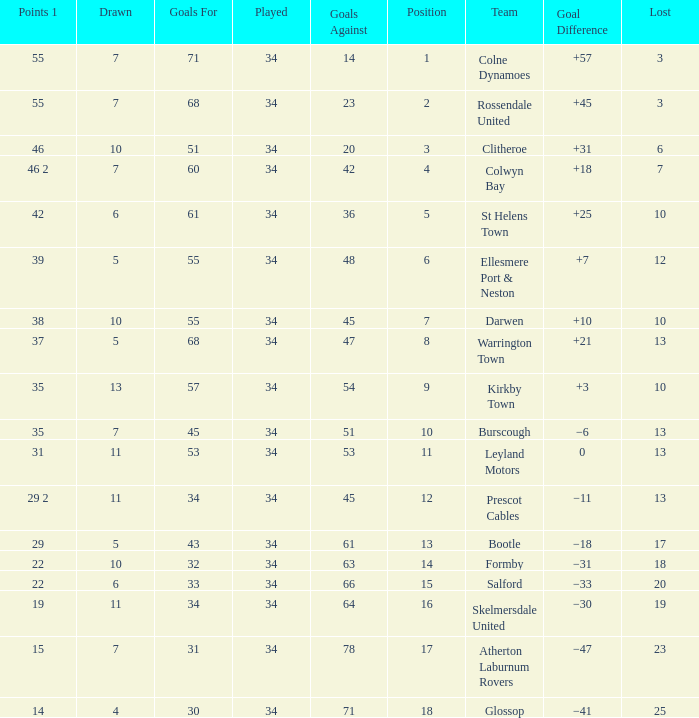Help me parse the entirety of this table. {'header': ['Points 1', 'Drawn', 'Goals For', 'Played', 'Goals Against', 'Position', 'Team', 'Goal Difference', 'Lost'], 'rows': [['55', '7', '71', '34', '14', '1', 'Colne Dynamoes', '+57', '3'], ['55', '7', '68', '34', '23', '2', 'Rossendale United', '+45', '3'], ['46', '10', '51', '34', '20', '3', 'Clitheroe', '+31', '6'], ['46 2', '7', '60', '34', '42', '4', 'Colwyn Bay', '+18', '7'], ['42', '6', '61', '34', '36', '5', 'St Helens Town', '+25', '10'], ['39', '5', '55', '34', '48', '6', 'Ellesmere Port & Neston', '+7', '12'], ['38', '10', '55', '34', '45', '7', 'Darwen', '+10', '10'], ['37', '5', '68', '34', '47', '8', 'Warrington Town', '+21', '13'], ['35', '13', '57', '34', '54', '9', 'Kirkby Town', '+3', '10'], ['35', '7', '45', '34', '51', '10', 'Burscough', '−6', '13'], ['31', '11', '53', '34', '53', '11', 'Leyland Motors', '0', '13'], ['29 2', '11', '34', '34', '45', '12', 'Prescot Cables', '−11', '13'], ['29', '5', '43', '34', '61', '13', 'Bootle', '−18', '17'], ['22', '10', '32', '34', '63', '14', 'Formby', '−31', '18'], ['22', '6', '33', '34', '66', '15', 'Salford', '−33', '20'], ['19', '11', '34', '34', '64', '16', 'Skelmersdale United', '−30', '19'], ['15', '7', '31', '34', '78', '17', 'Atherton Laburnum Rovers', '−47', '23'], ['14', '4', '30', '34', '71', '18', 'Glossop', '−41', '25']]} Which Position has 47 Goals Against, and a Played larger than 34? None. 